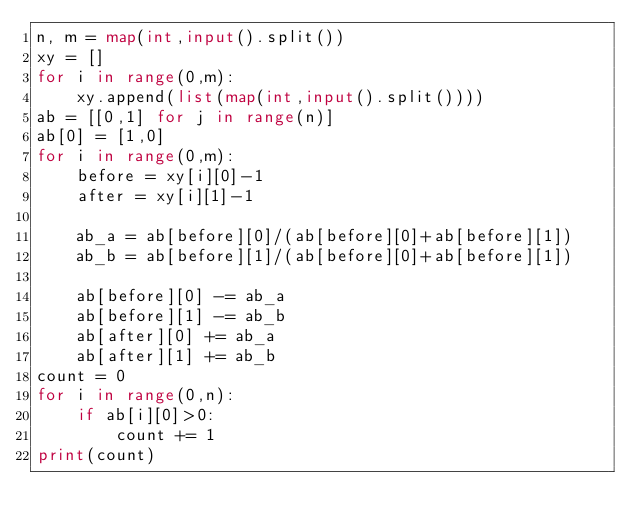Convert code to text. <code><loc_0><loc_0><loc_500><loc_500><_Python_>n, m = map(int,input().split())
xy = []
for i in range(0,m):
    xy.append(list(map(int,input().split())))
ab = [[0,1] for j in range(n)]
ab[0] = [1,0]
for i in range(0,m):
    before = xy[i][0]-1
    after = xy[i][1]-1

    ab_a = ab[before][0]/(ab[before][0]+ab[before][1])
    ab_b = ab[before][1]/(ab[before][0]+ab[before][1])
    
    ab[before][0] -= ab_a
    ab[before][1] -= ab_b
    ab[after][0] += ab_a
    ab[after][1] += ab_b
count = 0
for i in range(0,n):
    if ab[i][0]>0:
        count += 1
print(count)</code> 